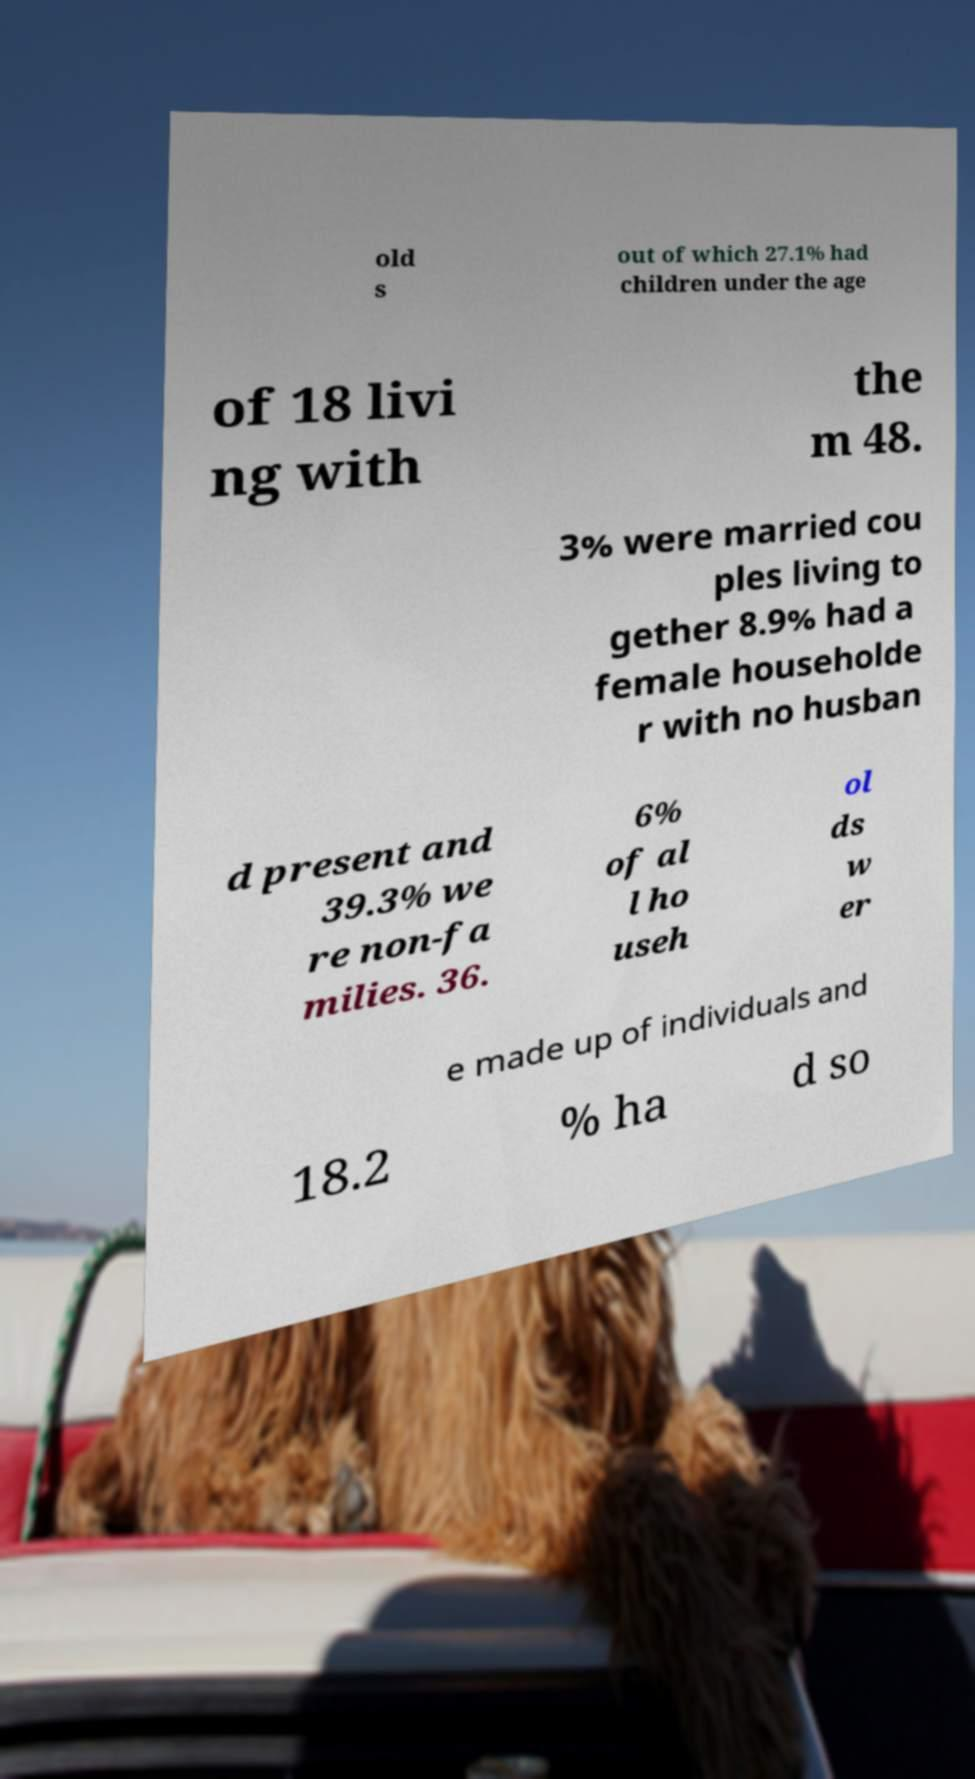Could you assist in decoding the text presented in this image and type it out clearly? old s out of which 27.1% had children under the age of 18 livi ng with the m 48. 3% were married cou ples living to gether 8.9% had a female householde r with no husban d present and 39.3% we re non-fa milies. 36. 6% of al l ho useh ol ds w er e made up of individuals and 18.2 % ha d so 